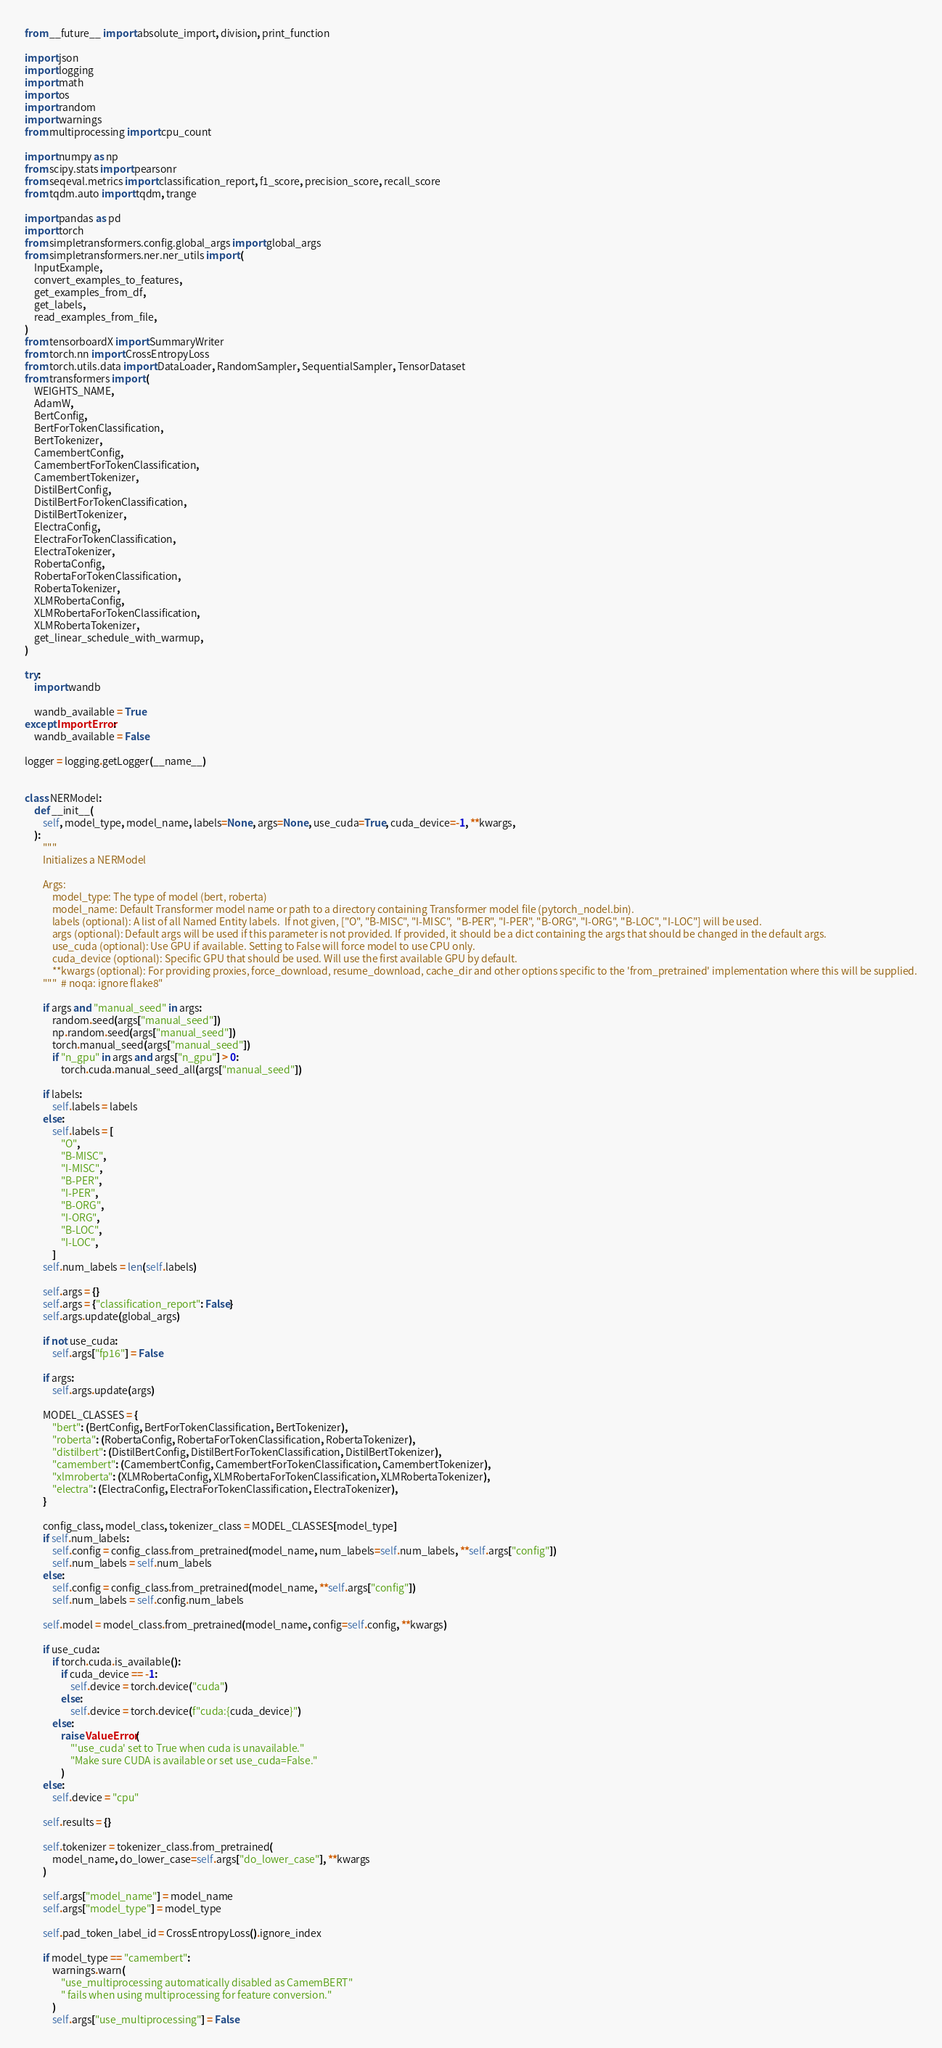Convert code to text. <code><loc_0><loc_0><loc_500><loc_500><_Python_>from __future__ import absolute_import, division, print_function

import json
import logging
import math
import os
import random
import warnings
from multiprocessing import cpu_count

import numpy as np
from scipy.stats import pearsonr
from seqeval.metrics import classification_report, f1_score, precision_score, recall_score
from tqdm.auto import tqdm, trange

import pandas as pd
import torch
from simpletransformers.config.global_args import global_args
from simpletransformers.ner.ner_utils import (
    InputExample,
    convert_examples_to_features,
    get_examples_from_df,
    get_labels,
    read_examples_from_file,
)
from tensorboardX import SummaryWriter
from torch.nn import CrossEntropyLoss
from torch.utils.data import DataLoader, RandomSampler, SequentialSampler, TensorDataset
from transformers import (
    WEIGHTS_NAME,
    AdamW,
    BertConfig,
    BertForTokenClassification,
    BertTokenizer,
    CamembertConfig,
    CamembertForTokenClassification,
    CamembertTokenizer,
    DistilBertConfig,
    DistilBertForTokenClassification,
    DistilBertTokenizer,
    ElectraConfig,
    ElectraForTokenClassification,
    ElectraTokenizer,
    RobertaConfig,
    RobertaForTokenClassification,
    RobertaTokenizer,
    XLMRobertaConfig,
    XLMRobertaForTokenClassification,
    XLMRobertaTokenizer,
    get_linear_schedule_with_warmup,
)

try:
    import wandb

    wandb_available = True
except ImportError:
    wandb_available = False

logger = logging.getLogger(__name__)


class NERModel:
    def __init__(
        self, model_type, model_name, labels=None, args=None, use_cuda=True, cuda_device=-1, **kwargs,
    ):
        """
        Initializes a NERModel

        Args:
            model_type: The type of model (bert, roberta)
            model_name: Default Transformer model name or path to a directory containing Transformer model file (pytorch_nodel.bin).
            labels (optional): A list of all Named Entity labels.  If not given, ["O", "B-MISC", "I-MISC",  "B-PER", "I-PER", "B-ORG", "I-ORG", "B-LOC", "I-LOC"] will be used.
            args (optional): Default args will be used if this parameter is not provided. If provided, it should be a dict containing the args that should be changed in the default args.
            use_cuda (optional): Use GPU if available. Setting to False will force model to use CPU only.
            cuda_device (optional): Specific GPU that should be used. Will use the first available GPU by default.
            **kwargs (optional): For providing proxies, force_download, resume_download, cache_dir and other options specific to the 'from_pretrained' implementation where this will be supplied.
        """  # noqa: ignore flake8"

        if args and "manual_seed" in args:
            random.seed(args["manual_seed"])
            np.random.seed(args["manual_seed"])
            torch.manual_seed(args["manual_seed"])
            if "n_gpu" in args and args["n_gpu"] > 0:
                torch.cuda.manual_seed_all(args["manual_seed"])

        if labels:
            self.labels = labels
        else:
            self.labels = [
                "O",
                "B-MISC",
                "I-MISC",
                "B-PER",
                "I-PER",
                "B-ORG",
                "I-ORG",
                "B-LOC",
                "I-LOC",
            ]
        self.num_labels = len(self.labels)

        self.args = {}
        self.args = {"classification_report": False}
        self.args.update(global_args)

        if not use_cuda:
            self.args["fp16"] = False

        if args:
            self.args.update(args)

        MODEL_CLASSES = {
            "bert": (BertConfig, BertForTokenClassification, BertTokenizer),
            "roberta": (RobertaConfig, RobertaForTokenClassification, RobertaTokenizer),
            "distilbert": (DistilBertConfig, DistilBertForTokenClassification, DistilBertTokenizer),
            "camembert": (CamembertConfig, CamembertForTokenClassification, CamembertTokenizer),
            "xlmroberta": (XLMRobertaConfig, XLMRobertaForTokenClassification, XLMRobertaTokenizer),
            "electra": (ElectraConfig, ElectraForTokenClassification, ElectraTokenizer),
        }

        config_class, model_class, tokenizer_class = MODEL_CLASSES[model_type]
        if self.num_labels:
            self.config = config_class.from_pretrained(model_name, num_labels=self.num_labels, **self.args["config"])
            self.num_labels = self.num_labels
        else:
            self.config = config_class.from_pretrained(model_name, **self.args["config"])
            self.num_labels = self.config.num_labels

        self.model = model_class.from_pretrained(model_name, config=self.config, **kwargs)

        if use_cuda:
            if torch.cuda.is_available():
                if cuda_device == -1:
                    self.device = torch.device("cuda")
                else:
                    self.device = torch.device(f"cuda:{cuda_device}")
            else:
                raise ValueError(
                    "'use_cuda' set to True when cuda is unavailable."
                    "Make sure CUDA is available or set use_cuda=False."
                )
        else:
            self.device = "cpu"

        self.results = {}

        self.tokenizer = tokenizer_class.from_pretrained(
            model_name, do_lower_case=self.args["do_lower_case"], **kwargs
        )

        self.args["model_name"] = model_name
        self.args["model_type"] = model_type

        self.pad_token_label_id = CrossEntropyLoss().ignore_index

        if model_type == "camembert":
            warnings.warn(
                "use_multiprocessing automatically disabled as CamemBERT"
                " fails when using multiprocessing for feature conversion."
            )
            self.args["use_multiprocessing"] = False
</code> 